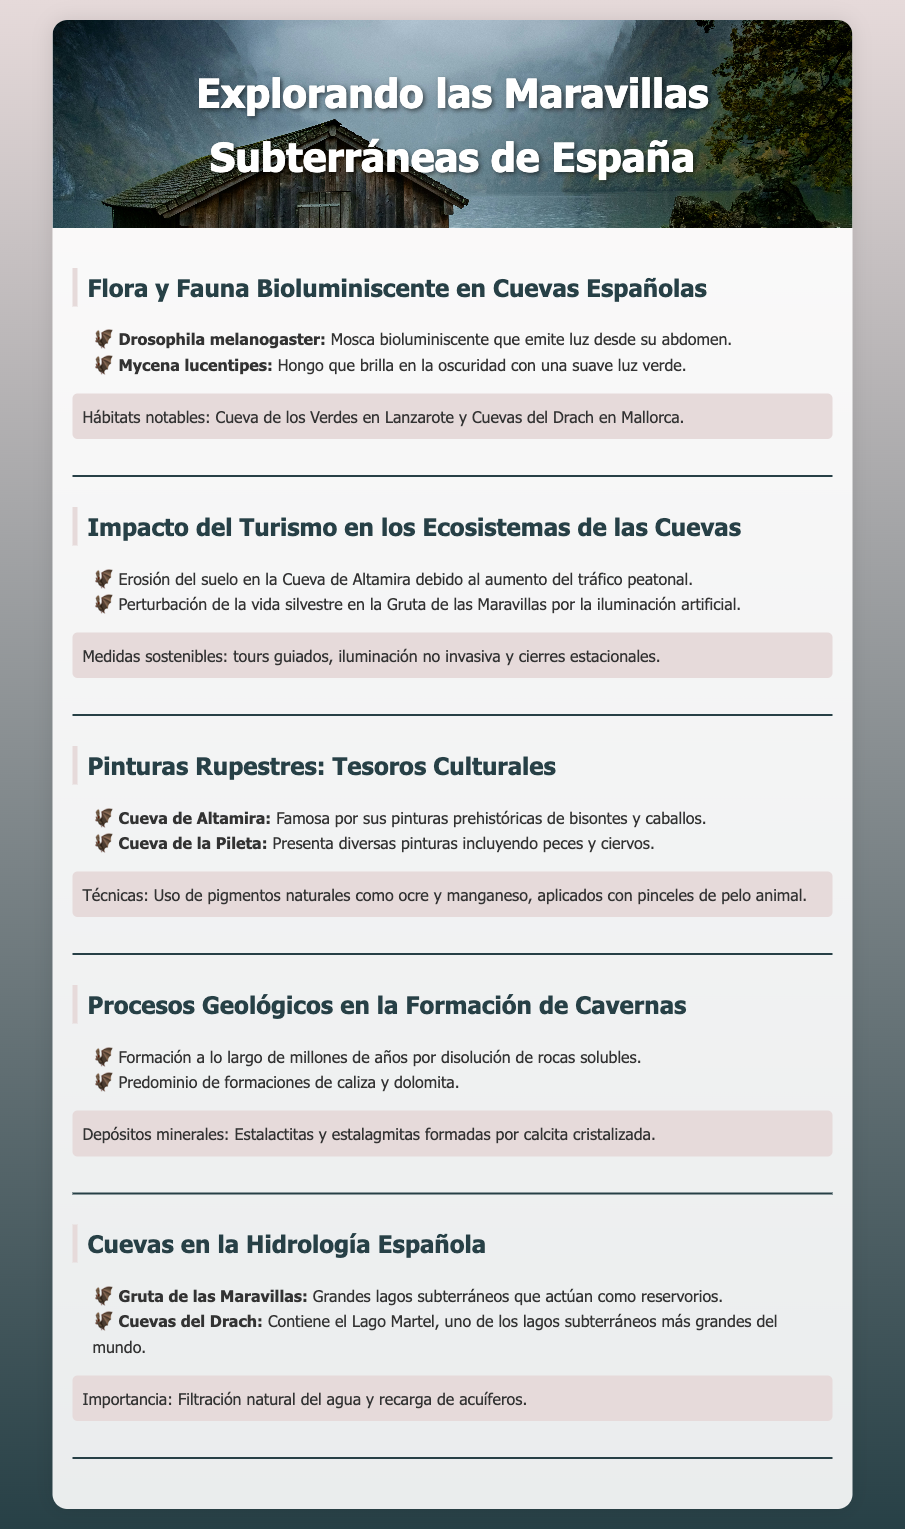What is the bioluminescent species found in Spanish caves? The document lists Drosophila melanogaster and Mycena lucentipes as bioluminescent species.
Answer: Drosophila melanogaster, Mycena lucentipes What is a notable habitat for bioluminescent flora and fauna? The document mentions Cueva de los Verdes in Lanzarote and Cuevas del Drach in Mallorca as notable habitats.
Answer: Cueva de los Verdes, Cuevas del Drach What is one impact of tourism on cave ecosystems? It states that erosion of soil occurs in the Cueva de Altamira due to increased foot traffic.
Answer: Erosión del suelo Name one cave that has significant rock paintings. The document lists Cueva de Altamira as a famous site for prehistoric paintings.
Answer: Cueva de Altamira What geological formations dominate Spanish cave systems? The document indicates that limestone and dolomite formations predominate in cave systems.
Answer: Caliza, dolomita What mineral formations are mentioned in the geological processes section? The document refers to stalactites and stalagmites formed by crystallized calcite.
Answer: Estalactitas, estalagmitas What is one measure for sustainable tourism mentioned? The document suggests guided tours as a measure for sustainable tourism in caves.
Answer: Tours guiados What is the function of caves in Spanish hydrology? Caves play a role in natural water filtration and aquifer recharge according to the document.
Answer: Filtración natural, recarga de acuíferos 